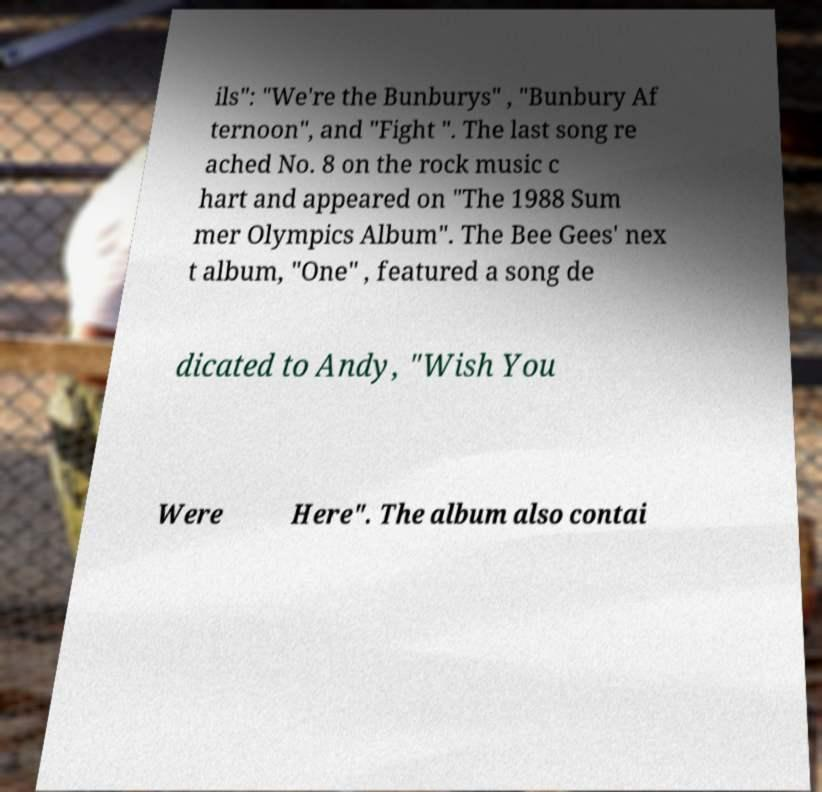There's text embedded in this image that I need extracted. Can you transcribe it verbatim? ils": "We're the Bunburys" , "Bunbury Af ternoon", and "Fight ". The last song re ached No. 8 on the rock music c hart and appeared on "The 1988 Sum mer Olympics Album". The Bee Gees' nex t album, "One" , featured a song de dicated to Andy, "Wish You Were Here". The album also contai 